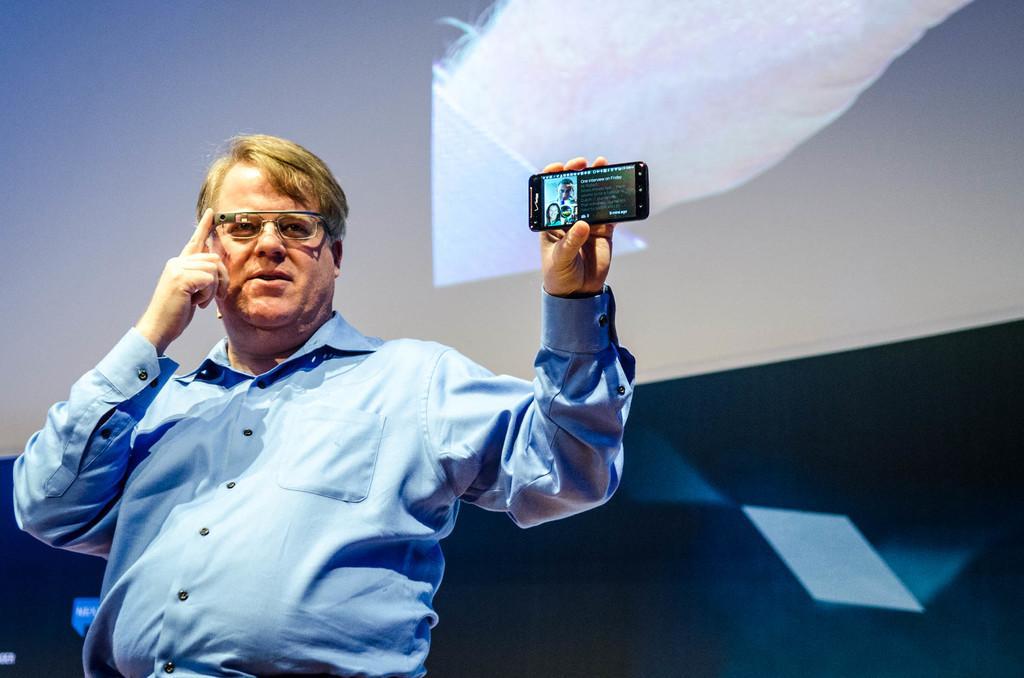Describe this image in one or two sentences. A man is standing on a stage and showing a mobile phone in his hand. 